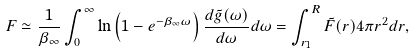Convert formula to latex. <formula><loc_0><loc_0><loc_500><loc_500>F \simeq \frac { 1 } { \beta _ { \infty } } \int _ { 0 } ^ { \infty } \ln \left ( 1 - e ^ { - \beta _ { \infty } \omega } \right ) \frac { d \tilde { g } ( \omega ) } { d \omega } d \omega = \int _ { r _ { 1 } } ^ { R } \tilde { F } ( r ) 4 \pi r ^ { 2 } d r ,</formula> 